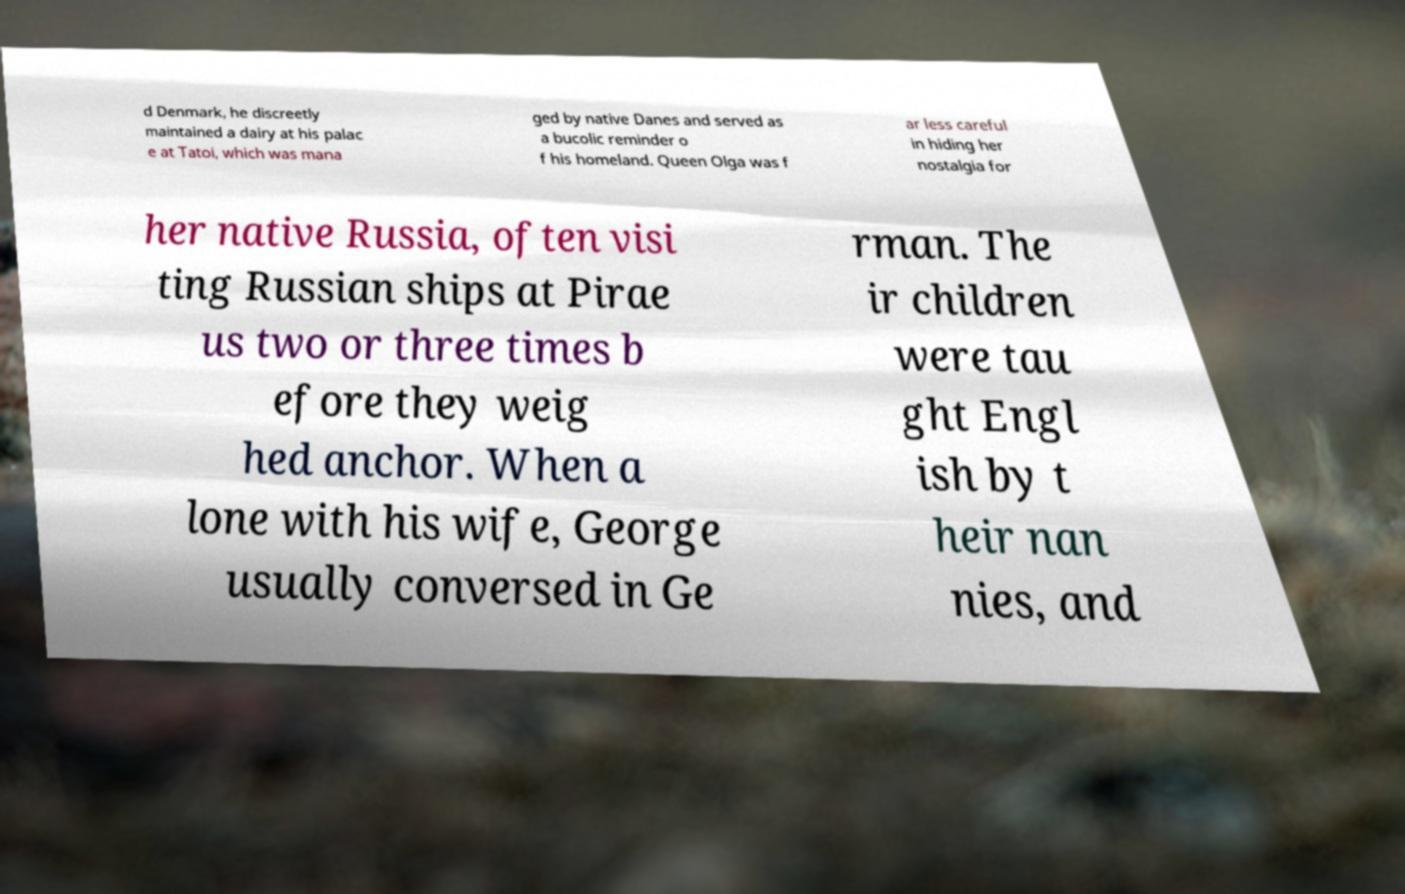What messages or text are displayed in this image? I need them in a readable, typed format. d Denmark, he discreetly maintained a dairy at his palac e at Tatoi, which was mana ged by native Danes and served as a bucolic reminder o f his homeland. Queen Olga was f ar less careful in hiding her nostalgia for her native Russia, often visi ting Russian ships at Pirae us two or three times b efore they weig hed anchor. When a lone with his wife, George usually conversed in Ge rman. The ir children were tau ght Engl ish by t heir nan nies, and 